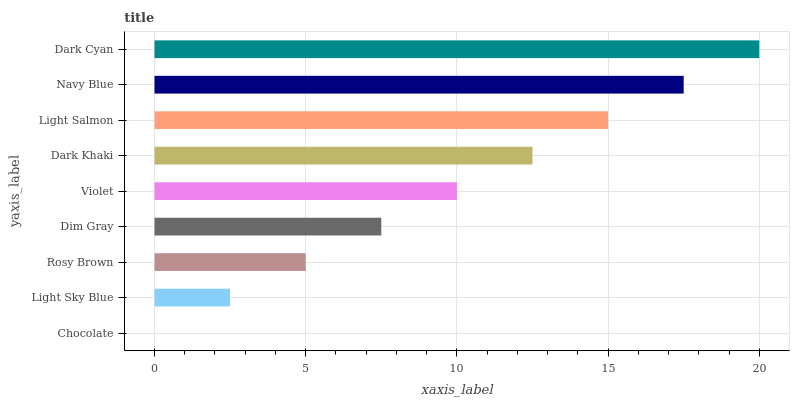Is Chocolate the minimum?
Answer yes or no. Yes. Is Dark Cyan the maximum?
Answer yes or no. Yes. Is Light Sky Blue the minimum?
Answer yes or no. No. Is Light Sky Blue the maximum?
Answer yes or no. No. Is Light Sky Blue greater than Chocolate?
Answer yes or no. Yes. Is Chocolate less than Light Sky Blue?
Answer yes or no. Yes. Is Chocolate greater than Light Sky Blue?
Answer yes or no. No. Is Light Sky Blue less than Chocolate?
Answer yes or no. No. Is Violet the high median?
Answer yes or no. Yes. Is Violet the low median?
Answer yes or no. Yes. Is Rosy Brown the high median?
Answer yes or no. No. Is Light Sky Blue the low median?
Answer yes or no. No. 